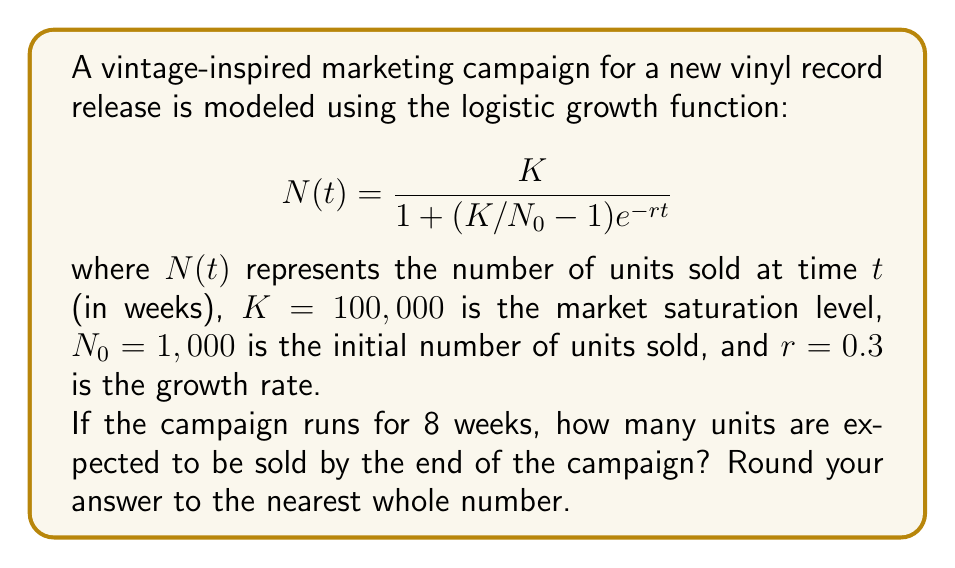Solve this math problem. To solve this problem, we need to follow these steps:

1. Identify the given parameters:
   $K = 100,000$ (market saturation level)
   $N_0 = 1,000$ (initial number of units sold)
   $r = 0.3$ (growth rate)
   $t = 8$ (campaign duration in weeks)

2. Substitute these values into the logistic growth function:

   $$N(8) = \frac{100,000}{1 + (100,000/1,000 - 1)e^{-0.3 \cdot 8}}$$

3. Simplify the expression inside the parentheses:
   
   $$N(8) = \frac{100,000}{1 + (100 - 1)e^{-2.4}}$$
   
   $$N(8) = \frac{100,000}{1 + 99e^{-2.4}}$$

4. Calculate $e^{-2.4}$ (you can use a calculator for this):
   
   $e^{-2.4} \approx 0.0907$

5. Substitute this value:

   $$N(8) = \frac{100,000}{1 + 99 \cdot 0.0907}$$
   
   $$N(8) = \frac{100,000}{1 + 8.9793}$$
   
   $$N(8) = \frac{100,000}{9.9793}$$

6. Perform the final division:

   $$N(8) \approx 10,020.14$$

7. Round to the nearest whole number:

   $$N(8) \approx 10,020$$
Answer: 10,020 units 